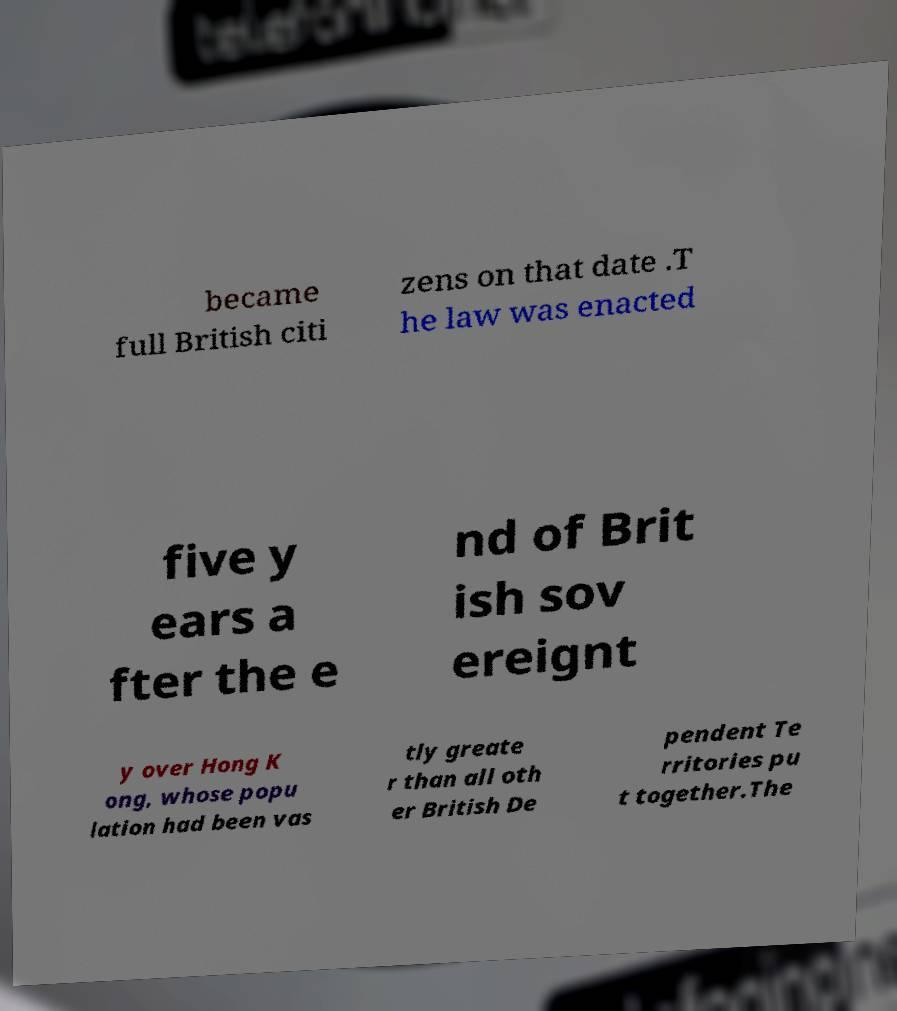Can you read and provide the text displayed in the image?This photo seems to have some interesting text. Can you extract and type it out for me? became full British citi zens on that date .T he law was enacted five y ears a fter the e nd of Brit ish sov ereignt y over Hong K ong, whose popu lation had been vas tly greate r than all oth er British De pendent Te rritories pu t together.The 